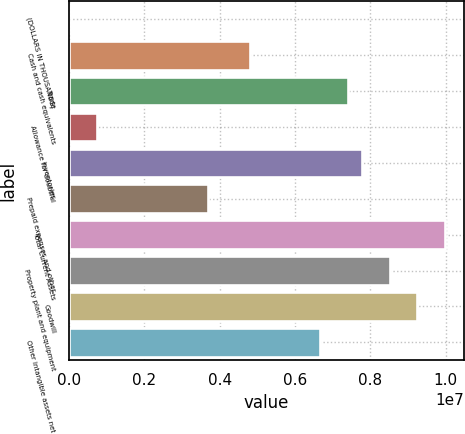Convert chart. <chart><loc_0><loc_0><loc_500><loc_500><bar_chart><fcel>(DOLLARS IN THOUSANDS)<fcel>Cash and cash equivalents<fcel>Trade<fcel>Allowance for doubtful<fcel>Inventories<fcel>Prepaid expenses and other<fcel>Total Current Assets<fcel>Property plant and equipment<fcel>Goodwill<fcel>Other intangible assets net<nl><fcel>2015<fcel>4.81201e+06<fcel>7.402e+06<fcel>742014<fcel>7.772e+06<fcel>3.70201e+06<fcel>9.992e+06<fcel>8.512e+06<fcel>9.252e+06<fcel>6.66201e+06<nl></chart> 